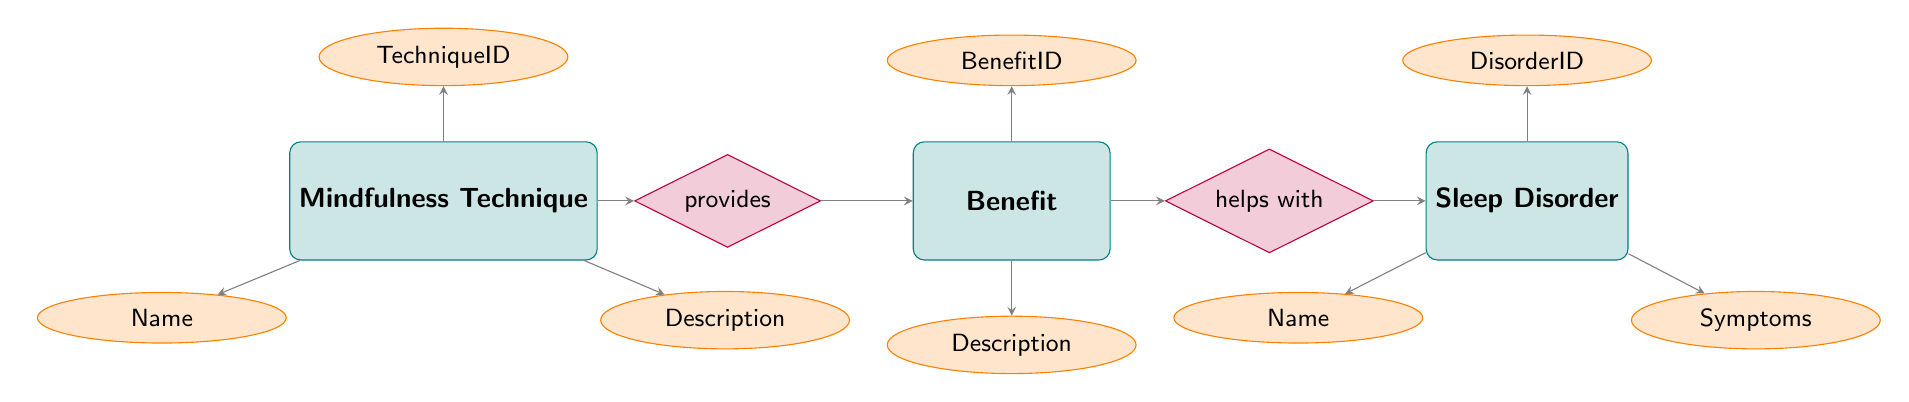What is the relationship between Mindfulness Technique and Benefit? The diagram shows that the relationship between Mindfulness Technique and Benefit is labeled as "provides." This indicates that mindfulness techniques provide various benefits relevant to sleep improvement.
Answer: provides How many mindfulness techniques are listed in the diagram? Looking at the instances, there are three mindfulness techniques mentioned: Mindful Breathing, Body Scan Meditation, and Loving-Kindness Meditation. This number is derived from counting the techniques displayed in the Mindfulness Technique entity.
Answer: 3 What benefit is associated with Body Scan Meditation? The diagram indicates that Body Scan Meditation provides two benefits: "Improves sleep quality" and "Enhances relaxation." Since both benefits are available from the relationship lines connected to Body Scan Meditation, one can infer the association.
Answer: Improves sleep quality, Enhances relaxation Which sleep disorder is helped by the benefit "Decreases insomnia symptoms"? Tracing the arrows in the diagram, the "Decreases insomnia symptoms" benefit (BenefitID 3) is linked to the Sleep Disorder entity representing "Insomnia." Thus, the disorder that this benefit helps with is clearly identified.
Answer: Insomnia What are the symptoms of Sleep Apnea? According to the Sleep Disorder entity in the diagram, the symptoms associated with Sleep Apnea are "Interrupted breathing during sleep, loud snoring, feeling tired even after a full night's sleep." This information is found directly within the attributes listed for the Sleep Apnea node.
Answer: Interrupted breathing during sleep, loud snoring, feeling tired even after a full night's sleep Which mindfulness technique helps reduce anxiety? The diagram indicates that both "Mindful Breathing" and "Loving-Kindness Meditation" offer the benefit of reducing anxiety. By examining the relationships, we can ascertain that these two specific techniques have this common benefit.
Answer: Mindful Breathing, Loving-Kindness Meditation What is the BenefitID of "Enhances relaxation"? Referring to the Benefit entity, "Enhances relaxation" corresponds to BenefitID 4. The attributes and ids provide a clear connection between benefits and their identifiers in the diagram.
Answer: 4 Which mindfulness technique provides the most benefits in the diagram? Analyzing the relationships of each technique, Body Scan Meditation provides two benefits, while Mindful Breathing and Loving-Kindness Meditation also provide two benefits each. However, all mindfulness techniques contribute similarly regarding the number of benefits.
Answer: All provide two benefits each 